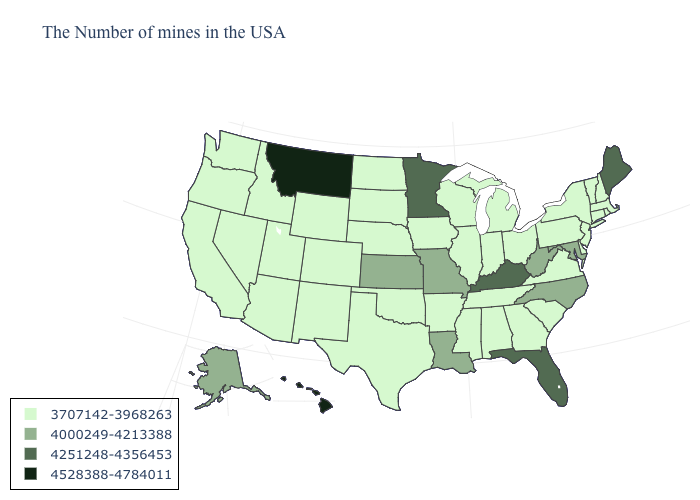Name the states that have a value in the range 4000249-4213388?
Keep it brief. Maryland, North Carolina, West Virginia, Louisiana, Missouri, Kansas, Alaska. How many symbols are there in the legend?
Quick response, please. 4. Name the states that have a value in the range 4528388-4784011?
Keep it brief. Montana, Hawaii. Does the map have missing data?
Write a very short answer. No. What is the value of Kansas?
Short answer required. 4000249-4213388. What is the lowest value in states that border Illinois?
Keep it brief. 3707142-3968263. What is the highest value in the MidWest ?
Be succinct. 4251248-4356453. Name the states that have a value in the range 4528388-4784011?
Give a very brief answer. Montana, Hawaii. Does West Virginia have a lower value than New York?
Short answer required. No. What is the highest value in the USA?
Write a very short answer. 4528388-4784011. Name the states that have a value in the range 3707142-3968263?
Be succinct. Massachusetts, Rhode Island, New Hampshire, Vermont, Connecticut, New York, New Jersey, Delaware, Pennsylvania, Virginia, South Carolina, Ohio, Georgia, Michigan, Indiana, Alabama, Tennessee, Wisconsin, Illinois, Mississippi, Arkansas, Iowa, Nebraska, Oklahoma, Texas, South Dakota, North Dakota, Wyoming, Colorado, New Mexico, Utah, Arizona, Idaho, Nevada, California, Washington, Oregon. Which states have the lowest value in the USA?
Answer briefly. Massachusetts, Rhode Island, New Hampshire, Vermont, Connecticut, New York, New Jersey, Delaware, Pennsylvania, Virginia, South Carolina, Ohio, Georgia, Michigan, Indiana, Alabama, Tennessee, Wisconsin, Illinois, Mississippi, Arkansas, Iowa, Nebraska, Oklahoma, Texas, South Dakota, North Dakota, Wyoming, Colorado, New Mexico, Utah, Arizona, Idaho, Nevada, California, Washington, Oregon. Name the states that have a value in the range 3707142-3968263?
Quick response, please. Massachusetts, Rhode Island, New Hampshire, Vermont, Connecticut, New York, New Jersey, Delaware, Pennsylvania, Virginia, South Carolina, Ohio, Georgia, Michigan, Indiana, Alabama, Tennessee, Wisconsin, Illinois, Mississippi, Arkansas, Iowa, Nebraska, Oklahoma, Texas, South Dakota, North Dakota, Wyoming, Colorado, New Mexico, Utah, Arizona, Idaho, Nevada, California, Washington, Oregon. Name the states that have a value in the range 3707142-3968263?
Quick response, please. Massachusetts, Rhode Island, New Hampshire, Vermont, Connecticut, New York, New Jersey, Delaware, Pennsylvania, Virginia, South Carolina, Ohio, Georgia, Michigan, Indiana, Alabama, Tennessee, Wisconsin, Illinois, Mississippi, Arkansas, Iowa, Nebraska, Oklahoma, Texas, South Dakota, North Dakota, Wyoming, Colorado, New Mexico, Utah, Arizona, Idaho, Nevada, California, Washington, Oregon. 